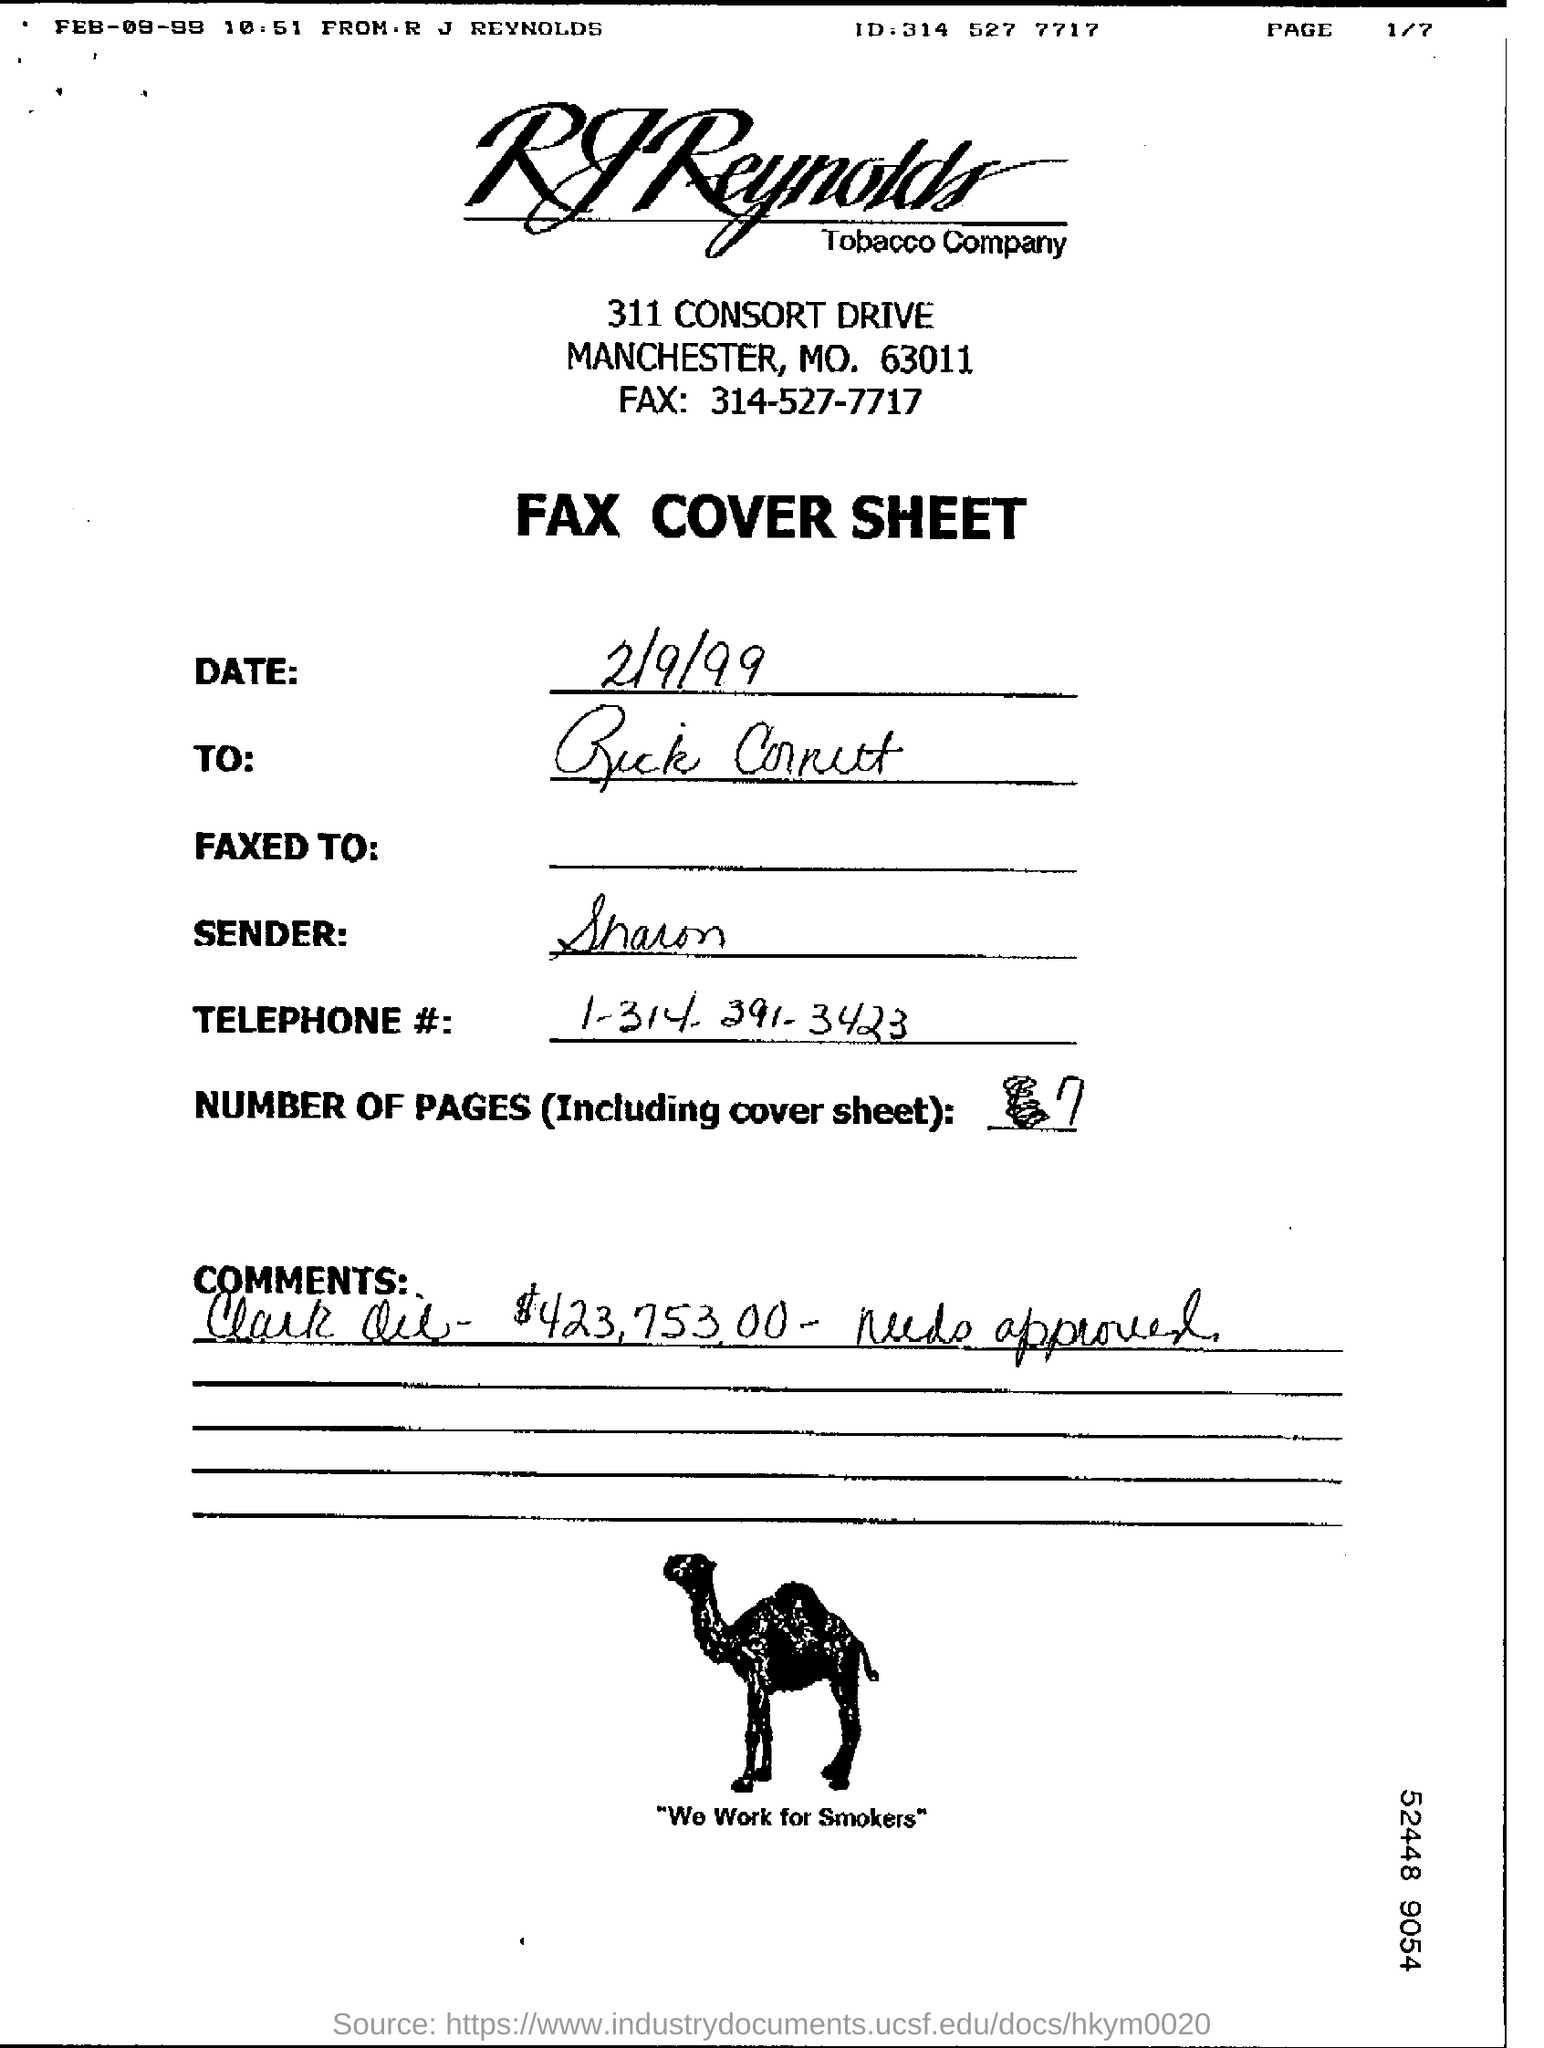Who is the sender ?
Provide a short and direct response. Sharon. What are the total number of pages (Including cover sheet) ?
Give a very brief answer. 7. 